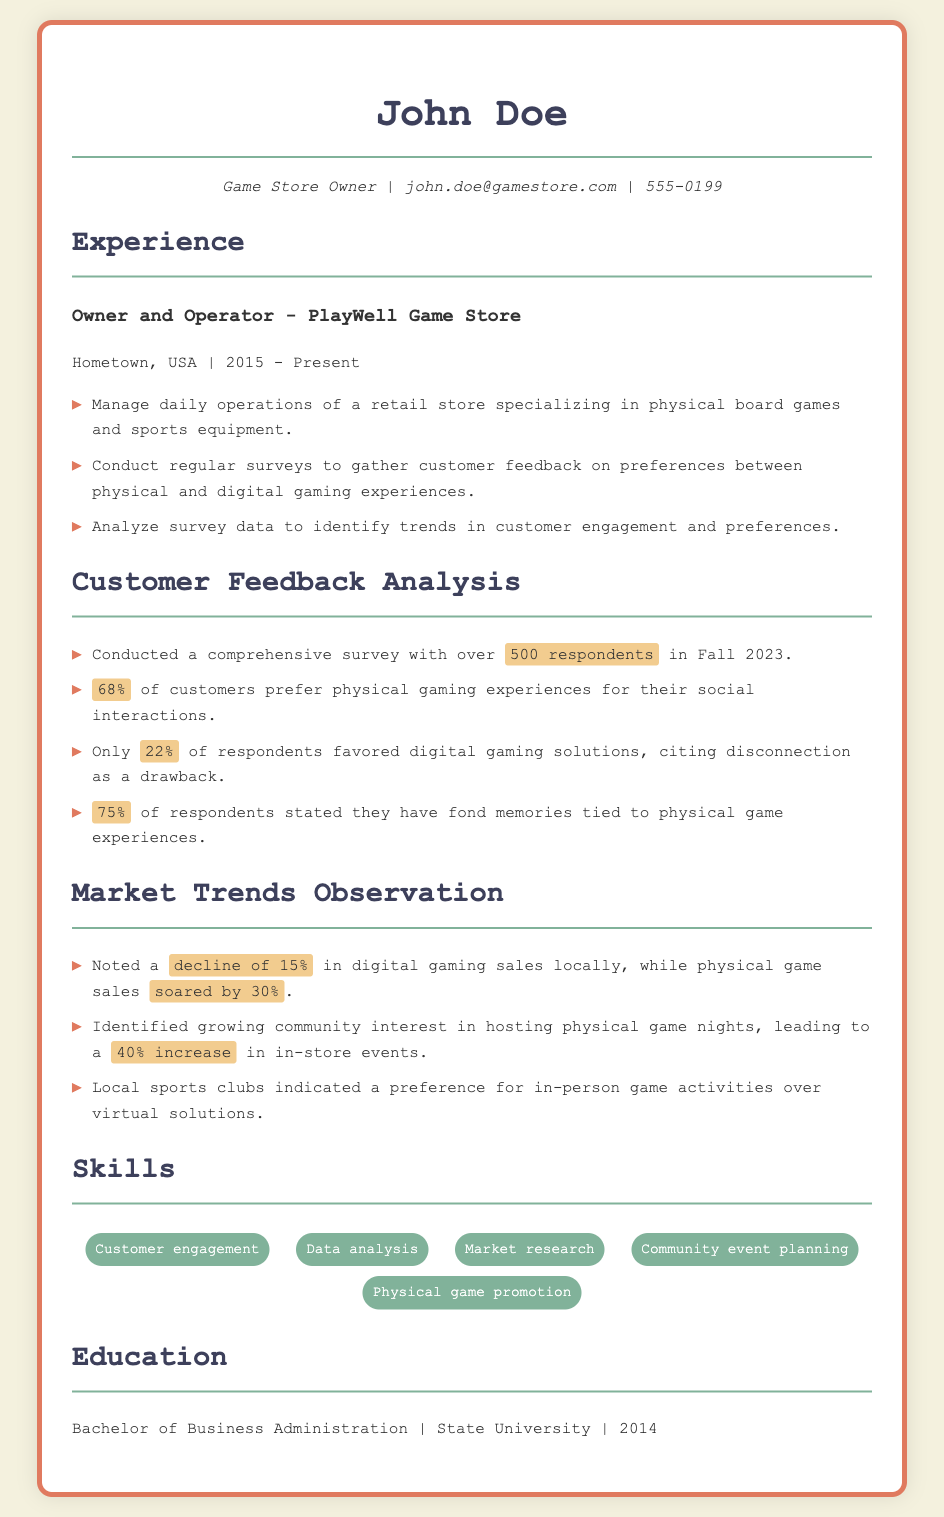What is the name of the game store owner? The name is mentioned at the top of the resume as "John Doe."
Answer: John Doe What percentage of customers prefer physical gaming experiences? The document states that 68% of customers prefer physical gaming experiences.
Answer: 68% How many respondents participated in the survey? The document provides the number of respondents as over 500.
Answer: 500 What was the increase in physical game sales? The document notes a 30% increase in physical game sales.
Answer: 30% What year did the game store owner start operating? The experience section states that he started in the year 2015.
Answer: 2015 What is the main reason cited by respondents for favoring digital solutions? The respondents cited "disconnection" as a drawback of digital gaming solutions.
Answer: disconnection What type of education does John Doe have? The education section indicates he has a Bachelor of Business Administration.
Answer: Bachelor of Business Administration What percentage of respondents have fond memories tied to physical gaming experiences? The document states that 75% of respondents have fond memories related to physical gaming experiences.
Answer: 75% What trend was noted in digital gaming sales? The document indicates a decline of 15% in digital gaming sales locally.
Answer: decline of 15% 